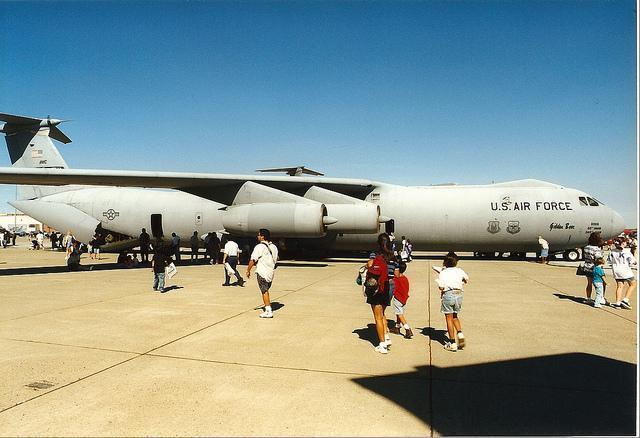How many people are in the photo?
Give a very brief answer. 3. 